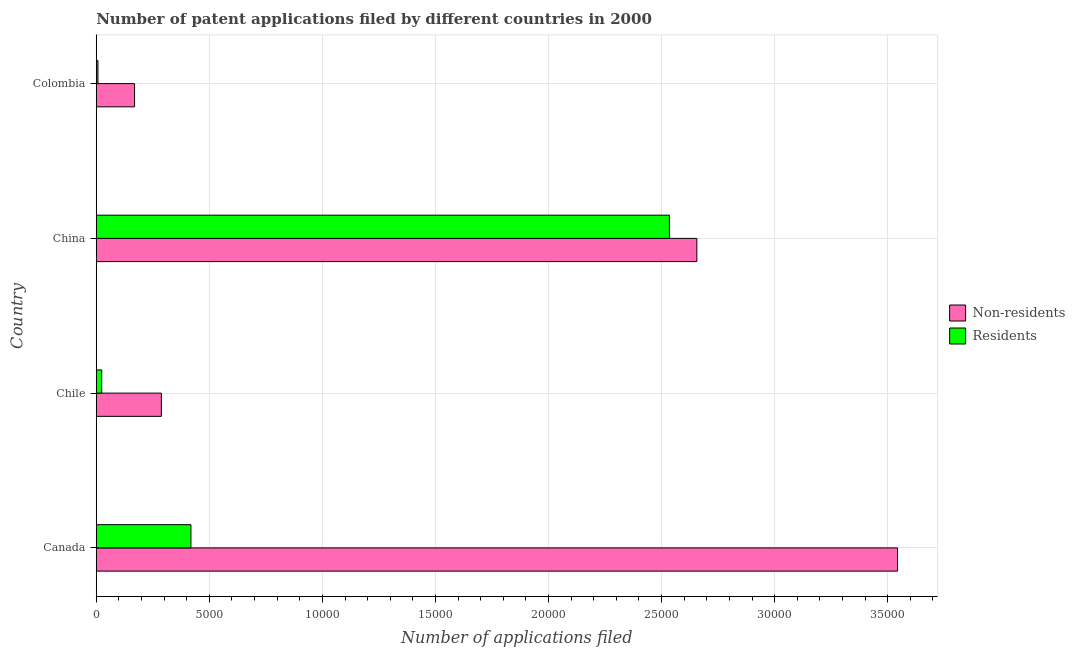How many groups of bars are there?
Make the answer very short. 4. How many bars are there on the 2nd tick from the top?
Make the answer very short. 2. How many bars are there on the 1st tick from the bottom?
Keep it short and to the point. 2. What is the number of patent applications by residents in Canada?
Offer a terse response. 4187. Across all countries, what is the maximum number of patent applications by residents?
Offer a very short reply. 2.53e+04. Across all countries, what is the minimum number of patent applications by non residents?
Your response must be concise. 1694. In which country was the number of patent applications by residents maximum?
Offer a very short reply. China. In which country was the number of patent applications by non residents minimum?
Ensure brevity in your answer.  Colombia. What is the total number of patent applications by non residents in the graph?
Provide a short and direct response. 6.66e+04. What is the difference between the number of patent applications by residents in Canada and that in Chile?
Provide a succinct answer. 3946. What is the difference between the number of patent applications by residents in China and the number of patent applications by non residents in Chile?
Provide a succinct answer. 2.25e+04. What is the average number of patent applications by residents per country?
Your answer should be very brief. 7462.25. What is the difference between the number of patent applications by residents and number of patent applications by non residents in China?
Provide a short and direct response. -1214. What is the ratio of the number of patent applications by residents in Canada to that in China?
Make the answer very short. 0.17. Is the difference between the number of patent applications by non residents in Canada and China greater than the difference between the number of patent applications by residents in Canada and China?
Your response must be concise. Yes. What is the difference between the highest and the second highest number of patent applications by residents?
Offer a very short reply. 2.12e+04. What is the difference between the highest and the lowest number of patent applications by non residents?
Provide a succinct answer. 3.37e+04. In how many countries, is the number of patent applications by residents greater than the average number of patent applications by residents taken over all countries?
Keep it short and to the point. 1. Is the sum of the number of patent applications by residents in Canada and Chile greater than the maximum number of patent applications by non residents across all countries?
Make the answer very short. No. What does the 2nd bar from the top in Colombia represents?
Provide a succinct answer. Non-residents. What does the 1st bar from the bottom in China represents?
Provide a short and direct response. Non-residents. Are all the bars in the graph horizontal?
Provide a succinct answer. Yes. What is the difference between two consecutive major ticks on the X-axis?
Ensure brevity in your answer.  5000. Does the graph contain any zero values?
Give a very brief answer. No. Does the graph contain grids?
Ensure brevity in your answer.  Yes. Where does the legend appear in the graph?
Your response must be concise. Center right. How are the legend labels stacked?
Provide a short and direct response. Vertical. What is the title of the graph?
Provide a short and direct response. Number of patent applications filed by different countries in 2000. What is the label or title of the X-axis?
Your answer should be very brief. Number of applications filed. What is the Number of applications filed of Non-residents in Canada?
Your response must be concise. 3.54e+04. What is the Number of applications filed in Residents in Canada?
Ensure brevity in your answer.  4187. What is the Number of applications filed in Non-residents in Chile?
Ensure brevity in your answer.  2879. What is the Number of applications filed in Residents in Chile?
Your answer should be compact. 241. What is the Number of applications filed of Non-residents in China?
Offer a very short reply. 2.66e+04. What is the Number of applications filed of Residents in China?
Provide a succinct answer. 2.53e+04. What is the Number of applications filed of Non-residents in Colombia?
Your response must be concise. 1694. What is the Number of applications filed in Residents in Colombia?
Provide a succinct answer. 75. Across all countries, what is the maximum Number of applications filed of Non-residents?
Keep it short and to the point. 3.54e+04. Across all countries, what is the maximum Number of applications filed in Residents?
Offer a very short reply. 2.53e+04. Across all countries, what is the minimum Number of applications filed in Non-residents?
Give a very brief answer. 1694. Across all countries, what is the minimum Number of applications filed of Residents?
Make the answer very short. 75. What is the total Number of applications filed in Non-residents in the graph?
Offer a terse response. 6.66e+04. What is the total Number of applications filed of Residents in the graph?
Provide a succinct answer. 2.98e+04. What is the difference between the Number of applications filed in Non-residents in Canada and that in Chile?
Keep it short and to the point. 3.26e+04. What is the difference between the Number of applications filed in Residents in Canada and that in Chile?
Your answer should be very brief. 3946. What is the difference between the Number of applications filed in Non-residents in Canada and that in China?
Provide a short and direct response. 8875. What is the difference between the Number of applications filed of Residents in Canada and that in China?
Offer a very short reply. -2.12e+04. What is the difference between the Number of applications filed of Non-residents in Canada and that in Colombia?
Provide a short and direct response. 3.37e+04. What is the difference between the Number of applications filed of Residents in Canada and that in Colombia?
Your answer should be very brief. 4112. What is the difference between the Number of applications filed of Non-residents in Chile and that in China?
Offer a very short reply. -2.37e+04. What is the difference between the Number of applications filed of Residents in Chile and that in China?
Your response must be concise. -2.51e+04. What is the difference between the Number of applications filed in Non-residents in Chile and that in Colombia?
Ensure brevity in your answer.  1185. What is the difference between the Number of applications filed in Residents in Chile and that in Colombia?
Make the answer very short. 166. What is the difference between the Number of applications filed in Non-residents in China and that in Colombia?
Provide a short and direct response. 2.49e+04. What is the difference between the Number of applications filed in Residents in China and that in Colombia?
Give a very brief answer. 2.53e+04. What is the difference between the Number of applications filed in Non-residents in Canada and the Number of applications filed in Residents in Chile?
Provide a succinct answer. 3.52e+04. What is the difference between the Number of applications filed of Non-residents in Canada and the Number of applications filed of Residents in China?
Your response must be concise. 1.01e+04. What is the difference between the Number of applications filed in Non-residents in Canada and the Number of applications filed in Residents in Colombia?
Provide a short and direct response. 3.54e+04. What is the difference between the Number of applications filed in Non-residents in Chile and the Number of applications filed in Residents in China?
Your answer should be very brief. -2.25e+04. What is the difference between the Number of applications filed of Non-residents in Chile and the Number of applications filed of Residents in Colombia?
Your response must be concise. 2804. What is the difference between the Number of applications filed in Non-residents in China and the Number of applications filed in Residents in Colombia?
Your answer should be very brief. 2.65e+04. What is the average Number of applications filed of Non-residents per country?
Your answer should be compact. 1.66e+04. What is the average Number of applications filed of Residents per country?
Offer a very short reply. 7462.25. What is the difference between the Number of applications filed in Non-residents and Number of applications filed in Residents in Canada?
Give a very brief answer. 3.12e+04. What is the difference between the Number of applications filed in Non-residents and Number of applications filed in Residents in Chile?
Keep it short and to the point. 2638. What is the difference between the Number of applications filed of Non-residents and Number of applications filed of Residents in China?
Offer a very short reply. 1214. What is the difference between the Number of applications filed of Non-residents and Number of applications filed of Residents in Colombia?
Make the answer very short. 1619. What is the ratio of the Number of applications filed of Non-residents in Canada to that in Chile?
Provide a succinct answer. 12.31. What is the ratio of the Number of applications filed of Residents in Canada to that in Chile?
Make the answer very short. 17.37. What is the ratio of the Number of applications filed of Non-residents in Canada to that in China?
Your answer should be compact. 1.33. What is the ratio of the Number of applications filed in Residents in Canada to that in China?
Make the answer very short. 0.17. What is the ratio of the Number of applications filed of Non-residents in Canada to that in Colombia?
Make the answer very short. 20.92. What is the ratio of the Number of applications filed of Residents in Canada to that in Colombia?
Your answer should be very brief. 55.83. What is the ratio of the Number of applications filed of Non-residents in Chile to that in China?
Keep it short and to the point. 0.11. What is the ratio of the Number of applications filed of Residents in Chile to that in China?
Provide a short and direct response. 0.01. What is the ratio of the Number of applications filed of Non-residents in Chile to that in Colombia?
Your answer should be compact. 1.7. What is the ratio of the Number of applications filed of Residents in Chile to that in Colombia?
Ensure brevity in your answer.  3.21. What is the ratio of the Number of applications filed of Non-residents in China to that in Colombia?
Offer a very short reply. 15.68. What is the ratio of the Number of applications filed of Residents in China to that in Colombia?
Ensure brevity in your answer.  337.95. What is the difference between the highest and the second highest Number of applications filed of Non-residents?
Provide a succinct answer. 8875. What is the difference between the highest and the second highest Number of applications filed of Residents?
Give a very brief answer. 2.12e+04. What is the difference between the highest and the lowest Number of applications filed of Non-residents?
Make the answer very short. 3.37e+04. What is the difference between the highest and the lowest Number of applications filed in Residents?
Keep it short and to the point. 2.53e+04. 